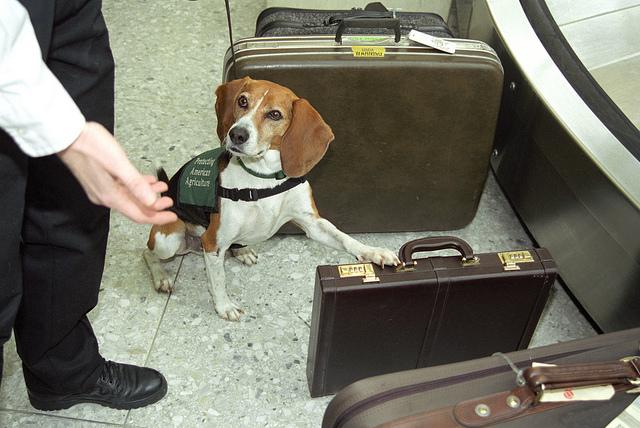Where is the dog's left paw?
Short answer required. On briefcase. Does the dog have a job?
Write a very short answer. Yes. Is this at an airport?
Give a very brief answer. Yes. 